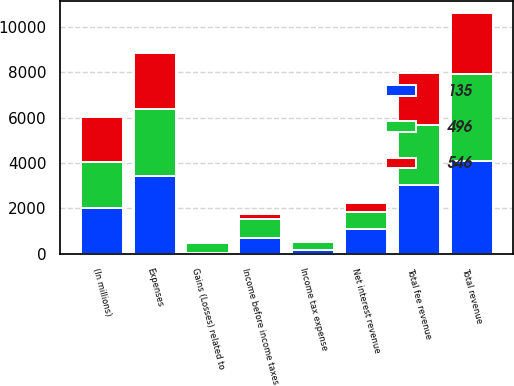Convert chart to OTSL. <chart><loc_0><loc_0><loc_500><loc_500><stacked_bar_chart><ecel><fcel>(In millions)<fcel>Total fee revenue<fcel>Net interest revenue<fcel>Gains (Losses) related to<fcel>Total revenue<fcel>Expenses<fcel>Income before income taxes<fcel>Income tax expense<nl><fcel>135<fcel>2011<fcel>3004<fcel>1104<fcel>25<fcel>4083<fcel>3415<fcel>668<fcel>172<nl><fcel>496<fcel>2010<fcel>2661<fcel>725<fcel>449<fcel>3835<fcel>2962<fcel>873<fcel>327<nl><fcel>546<fcel>2009<fcel>2291<fcel>422<fcel>37<fcel>2676<fcel>2457<fcel>219<fcel>84<nl></chart> 